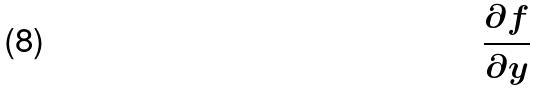<formula> <loc_0><loc_0><loc_500><loc_500>\frac { \partial f } { \partial y }</formula> 